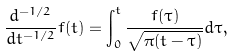Convert formula to latex. <formula><loc_0><loc_0><loc_500><loc_500>\frac { d ^ { - 1 / 2 } } { d t ^ { - 1 / 2 } } f ( t ) = \int _ { 0 } ^ { t } \frac { f ( \tau ) } { \sqrt { \pi ( t - \tau ) } } d \tau ,</formula> 